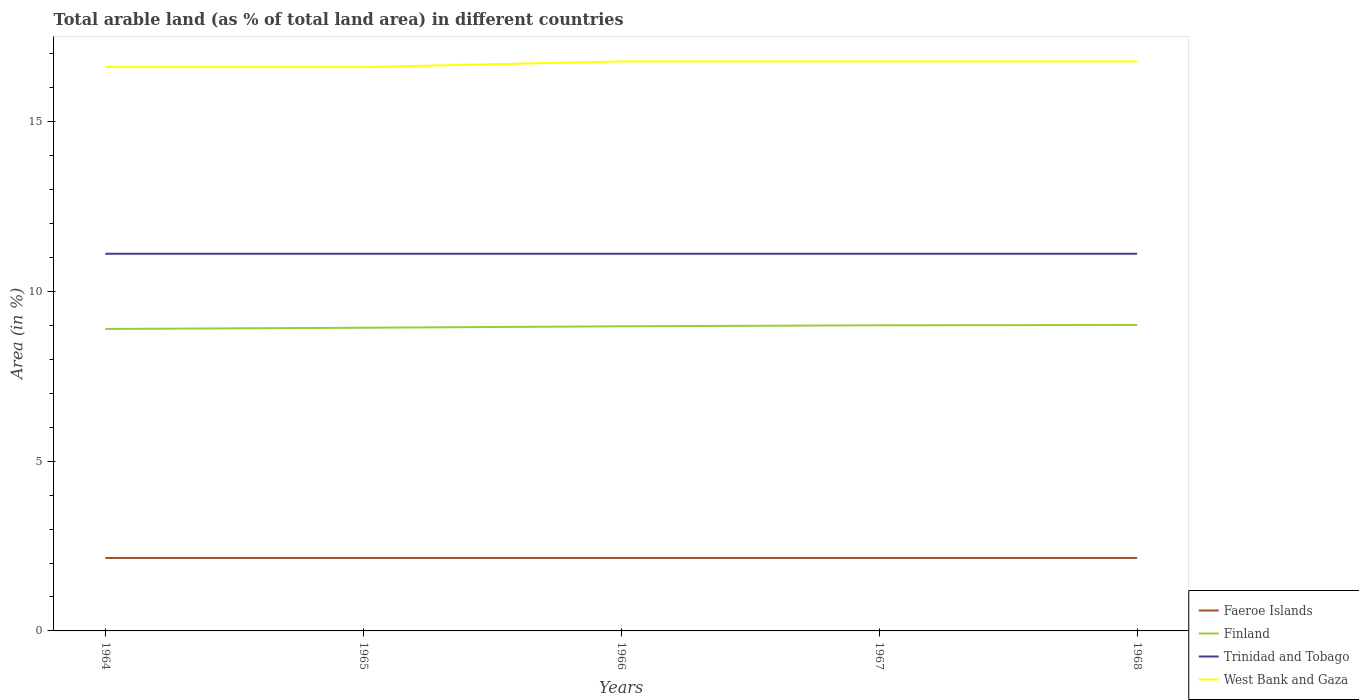Does the line corresponding to Finland intersect with the line corresponding to West Bank and Gaza?
Keep it short and to the point. No. Across all years, what is the maximum percentage of arable land in Faeroe Islands?
Offer a terse response. 2.15. In which year was the percentage of arable land in Faeroe Islands maximum?
Your answer should be compact. 1964. What is the difference between the highest and the second highest percentage of arable land in Trinidad and Tobago?
Keep it short and to the point. 0. Is the percentage of arable land in Trinidad and Tobago strictly greater than the percentage of arable land in West Bank and Gaza over the years?
Provide a short and direct response. Yes. How many lines are there?
Keep it short and to the point. 4. How many years are there in the graph?
Keep it short and to the point. 5. What is the difference between two consecutive major ticks on the Y-axis?
Provide a short and direct response. 5. Are the values on the major ticks of Y-axis written in scientific E-notation?
Offer a terse response. No. Does the graph contain any zero values?
Keep it short and to the point. No. Does the graph contain grids?
Your answer should be very brief. No. What is the title of the graph?
Your answer should be very brief. Total arable land (as % of total land area) in different countries. What is the label or title of the X-axis?
Provide a succinct answer. Years. What is the label or title of the Y-axis?
Offer a very short reply. Area (in %). What is the Area (in %) of Faeroe Islands in 1964?
Give a very brief answer. 2.15. What is the Area (in %) of Finland in 1964?
Give a very brief answer. 8.9. What is the Area (in %) of Trinidad and Tobago in 1964?
Offer a very short reply. 11.11. What is the Area (in %) in West Bank and Gaza in 1964?
Ensure brevity in your answer.  16.61. What is the Area (in %) in Faeroe Islands in 1965?
Make the answer very short. 2.15. What is the Area (in %) of Finland in 1965?
Offer a very short reply. 8.93. What is the Area (in %) of Trinidad and Tobago in 1965?
Offer a very short reply. 11.11. What is the Area (in %) in West Bank and Gaza in 1965?
Provide a short and direct response. 16.61. What is the Area (in %) in Faeroe Islands in 1966?
Offer a very short reply. 2.15. What is the Area (in %) in Finland in 1966?
Offer a terse response. 8.97. What is the Area (in %) in Trinidad and Tobago in 1966?
Offer a very short reply. 11.11. What is the Area (in %) in West Bank and Gaza in 1966?
Your response must be concise. 16.78. What is the Area (in %) in Faeroe Islands in 1967?
Ensure brevity in your answer.  2.15. What is the Area (in %) in Finland in 1967?
Give a very brief answer. 9. What is the Area (in %) of Trinidad and Tobago in 1967?
Provide a succinct answer. 11.11. What is the Area (in %) of West Bank and Gaza in 1967?
Provide a succinct answer. 16.78. What is the Area (in %) in Faeroe Islands in 1968?
Provide a short and direct response. 2.15. What is the Area (in %) of Finland in 1968?
Give a very brief answer. 9.01. What is the Area (in %) of Trinidad and Tobago in 1968?
Provide a short and direct response. 11.11. What is the Area (in %) in West Bank and Gaza in 1968?
Provide a succinct answer. 16.78. Across all years, what is the maximum Area (in %) of Faeroe Islands?
Provide a short and direct response. 2.15. Across all years, what is the maximum Area (in %) of Finland?
Offer a terse response. 9.01. Across all years, what is the maximum Area (in %) in Trinidad and Tobago?
Make the answer very short. 11.11. Across all years, what is the maximum Area (in %) in West Bank and Gaza?
Provide a succinct answer. 16.78. Across all years, what is the minimum Area (in %) of Faeroe Islands?
Give a very brief answer. 2.15. Across all years, what is the minimum Area (in %) of Finland?
Provide a succinct answer. 8.9. Across all years, what is the minimum Area (in %) of Trinidad and Tobago?
Make the answer very short. 11.11. Across all years, what is the minimum Area (in %) of West Bank and Gaza?
Provide a succinct answer. 16.61. What is the total Area (in %) of Faeroe Islands in the graph?
Provide a succinct answer. 10.74. What is the total Area (in %) of Finland in the graph?
Give a very brief answer. 44.82. What is the total Area (in %) of Trinidad and Tobago in the graph?
Keep it short and to the point. 55.56. What is the total Area (in %) of West Bank and Gaza in the graph?
Offer a terse response. 83.55. What is the difference between the Area (in %) in Faeroe Islands in 1964 and that in 1965?
Make the answer very short. 0. What is the difference between the Area (in %) of Finland in 1964 and that in 1965?
Make the answer very short. -0.04. What is the difference between the Area (in %) in West Bank and Gaza in 1964 and that in 1965?
Offer a terse response. 0. What is the difference between the Area (in %) in Faeroe Islands in 1964 and that in 1966?
Offer a very short reply. 0. What is the difference between the Area (in %) of Finland in 1964 and that in 1966?
Ensure brevity in your answer.  -0.08. What is the difference between the Area (in %) of Trinidad and Tobago in 1964 and that in 1966?
Your response must be concise. 0. What is the difference between the Area (in %) of West Bank and Gaza in 1964 and that in 1966?
Give a very brief answer. -0.17. What is the difference between the Area (in %) in Faeroe Islands in 1964 and that in 1967?
Your answer should be compact. 0. What is the difference between the Area (in %) of Finland in 1964 and that in 1967?
Give a very brief answer. -0.11. What is the difference between the Area (in %) in West Bank and Gaza in 1964 and that in 1967?
Provide a short and direct response. -0.17. What is the difference between the Area (in %) of Faeroe Islands in 1964 and that in 1968?
Keep it short and to the point. 0. What is the difference between the Area (in %) in Finland in 1964 and that in 1968?
Offer a terse response. -0.12. What is the difference between the Area (in %) in Trinidad and Tobago in 1964 and that in 1968?
Give a very brief answer. 0. What is the difference between the Area (in %) of West Bank and Gaza in 1964 and that in 1968?
Provide a short and direct response. -0.17. What is the difference between the Area (in %) of Finland in 1965 and that in 1966?
Offer a terse response. -0.04. What is the difference between the Area (in %) of Trinidad and Tobago in 1965 and that in 1966?
Offer a terse response. 0. What is the difference between the Area (in %) in West Bank and Gaza in 1965 and that in 1966?
Offer a very short reply. -0.17. What is the difference between the Area (in %) of Faeroe Islands in 1965 and that in 1967?
Provide a succinct answer. 0. What is the difference between the Area (in %) of Finland in 1965 and that in 1967?
Offer a terse response. -0.07. What is the difference between the Area (in %) in West Bank and Gaza in 1965 and that in 1967?
Your answer should be very brief. -0.17. What is the difference between the Area (in %) in Finland in 1965 and that in 1968?
Keep it short and to the point. -0.08. What is the difference between the Area (in %) in Trinidad and Tobago in 1965 and that in 1968?
Ensure brevity in your answer.  0. What is the difference between the Area (in %) of West Bank and Gaza in 1965 and that in 1968?
Keep it short and to the point. -0.17. What is the difference between the Area (in %) of Finland in 1966 and that in 1967?
Your answer should be compact. -0.03. What is the difference between the Area (in %) in Trinidad and Tobago in 1966 and that in 1967?
Make the answer very short. 0. What is the difference between the Area (in %) of West Bank and Gaza in 1966 and that in 1967?
Make the answer very short. 0. What is the difference between the Area (in %) in Faeroe Islands in 1966 and that in 1968?
Your answer should be compact. 0. What is the difference between the Area (in %) of Finland in 1966 and that in 1968?
Offer a very short reply. -0.04. What is the difference between the Area (in %) in Finland in 1967 and that in 1968?
Provide a succinct answer. -0.01. What is the difference between the Area (in %) of Trinidad and Tobago in 1967 and that in 1968?
Your answer should be very brief. 0. What is the difference between the Area (in %) of Faeroe Islands in 1964 and the Area (in %) of Finland in 1965?
Provide a succinct answer. -6.78. What is the difference between the Area (in %) of Faeroe Islands in 1964 and the Area (in %) of Trinidad and Tobago in 1965?
Offer a terse response. -8.96. What is the difference between the Area (in %) of Faeroe Islands in 1964 and the Area (in %) of West Bank and Gaza in 1965?
Offer a very short reply. -14.46. What is the difference between the Area (in %) in Finland in 1964 and the Area (in %) in Trinidad and Tobago in 1965?
Ensure brevity in your answer.  -2.22. What is the difference between the Area (in %) of Finland in 1964 and the Area (in %) of West Bank and Gaza in 1965?
Your response must be concise. -7.72. What is the difference between the Area (in %) in Trinidad and Tobago in 1964 and the Area (in %) in West Bank and Gaza in 1965?
Make the answer very short. -5.5. What is the difference between the Area (in %) in Faeroe Islands in 1964 and the Area (in %) in Finland in 1966?
Provide a short and direct response. -6.83. What is the difference between the Area (in %) of Faeroe Islands in 1964 and the Area (in %) of Trinidad and Tobago in 1966?
Offer a very short reply. -8.96. What is the difference between the Area (in %) of Faeroe Islands in 1964 and the Area (in %) of West Bank and Gaza in 1966?
Your answer should be compact. -14.63. What is the difference between the Area (in %) of Finland in 1964 and the Area (in %) of Trinidad and Tobago in 1966?
Provide a short and direct response. -2.22. What is the difference between the Area (in %) in Finland in 1964 and the Area (in %) in West Bank and Gaza in 1966?
Your answer should be very brief. -7.88. What is the difference between the Area (in %) of Trinidad and Tobago in 1964 and the Area (in %) of West Bank and Gaza in 1966?
Provide a short and direct response. -5.67. What is the difference between the Area (in %) in Faeroe Islands in 1964 and the Area (in %) in Finland in 1967?
Your answer should be compact. -6.85. What is the difference between the Area (in %) in Faeroe Islands in 1964 and the Area (in %) in Trinidad and Tobago in 1967?
Your response must be concise. -8.96. What is the difference between the Area (in %) of Faeroe Islands in 1964 and the Area (in %) of West Bank and Gaza in 1967?
Provide a short and direct response. -14.63. What is the difference between the Area (in %) of Finland in 1964 and the Area (in %) of Trinidad and Tobago in 1967?
Your answer should be very brief. -2.22. What is the difference between the Area (in %) of Finland in 1964 and the Area (in %) of West Bank and Gaza in 1967?
Ensure brevity in your answer.  -7.88. What is the difference between the Area (in %) of Trinidad and Tobago in 1964 and the Area (in %) of West Bank and Gaza in 1967?
Make the answer very short. -5.67. What is the difference between the Area (in %) of Faeroe Islands in 1964 and the Area (in %) of Finland in 1968?
Provide a short and direct response. -6.86. What is the difference between the Area (in %) in Faeroe Islands in 1964 and the Area (in %) in Trinidad and Tobago in 1968?
Give a very brief answer. -8.96. What is the difference between the Area (in %) of Faeroe Islands in 1964 and the Area (in %) of West Bank and Gaza in 1968?
Your answer should be very brief. -14.63. What is the difference between the Area (in %) in Finland in 1964 and the Area (in %) in Trinidad and Tobago in 1968?
Offer a very short reply. -2.22. What is the difference between the Area (in %) of Finland in 1964 and the Area (in %) of West Bank and Gaza in 1968?
Your answer should be compact. -7.88. What is the difference between the Area (in %) in Trinidad and Tobago in 1964 and the Area (in %) in West Bank and Gaza in 1968?
Make the answer very short. -5.67. What is the difference between the Area (in %) of Faeroe Islands in 1965 and the Area (in %) of Finland in 1966?
Your answer should be very brief. -6.83. What is the difference between the Area (in %) in Faeroe Islands in 1965 and the Area (in %) in Trinidad and Tobago in 1966?
Your answer should be compact. -8.96. What is the difference between the Area (in %) in Faeroe Islands in 1965 and the Area (in %) in West Bank and Gaza in 1966?
Give a very brief answer. -14.63. What is the difference between the Area (in %) in Finland in 1965 and the Area (in %) in Trinidad and Tobago in 1966?
Provide a short and direct response. -2.18. What is the difference between the Area (in %) of Finland in 1965 and the Area (in %) of West Bank and Gaza in 1966?
Your answer should be very brief. -7.85. What is the difference between the Area (in %) of Trinidad and Tobago in 1965 and the Area (in %) of West Bank and Gaza in 1966?
Provide a short and direct response. -5.67. What is the difference between the Area (in %) of Faeroe Islands in 1965 and the Area (in %) of Finland in 1967?
Your response must be concise. -6.85. What is the difference between the Area (in %) in Faeroe Islands in 1965 and the Area (in %) in Trinidad and Tobago in 1967?
Ensure brevity in your answer.  -8.96. What is the difference between the Area (in %) of Faeroe Islands in 1965 and the Area (in %) of West Bank and Gaza in 1967?
Ensure brevity in your answer.  -14.63. What is the difference between the Area (in %) in Finland in 1965 and the Area (in %) in Trinidad and Tobago in 1967?
Your answer should be compact. -2.18. What is the difference between the Area (in %) in Finland in 1965 and the Area (in %) in West Bank and Gaza in 1967?
Offer a very short reply. -7.85. What is the difference between the Area (in %) in Trinidad and Tobago in 1965 and the Area (in %) in West Bank and Gaza in 1967?
Provide a short and direct response. -5.67. What is the difference between the Area (in %) of Faeroe Islands in 1965 and the Area (in %) of Finland in 1968?
Provide a succinct answer. -6.86. What is the difference between the Area (in %) of Faeroe Islands in 1965 and the Area (in %) of Trinidad and Tobago in 1968?
Your answer should be compact. -8.96. What is the difference between the Area (in %) in Faeroe Islands in 1965 and the Area (in %) in West Bank and Gaza in 1968?
Offer a very short reply. -14.63. What is the difference between the Area (in %) in Finland in 1965 and the Area (in %) in Trinidad and Tobago in 1968?
Make the answer very short. -2.18. What is the difference between the Area (in %) of Finland in 1965 and the Area (in %) of West Bank and Gaza in 1968?
Your answer should be compact. -7.85. What is the difference between the Area (in %) of Trinidad and Tobago in 1965 and the Area (in %) of West Bank and Gaza in 1968?
Provide a short and direct response. -5.67. What is the difference between the Area (in %) in Faeroe Islands in 1966 and the Area (in %) in Finland in 1967?
Offer a very short reply. -6.85. What is the difference between the Area (in %) of Faeroe Islands in 1966 and the Area (in %) of Trinidad and Tobago in 1967?
Your response must be concise. -8.96. What is the difference between the Area (in %) in Faeroe Islands in 1966 and the Area (in %) in West Bank and Gaza in 1967?
Offer a terse response. -14.63. What is the difference between the Area (in %) of Finland in 1966 and the Area (in %) of Trinidad and Tobago in 1967?
Your response must be concise. -2.14. What is the difference between the Area (in %) of Finland in 1966 and the Area (in %) of West Bank and Gaza in 1967?
Provide a succinct answer. -7.8. What is the difference between the Area (in %) of Trinidad and Tobago in 1966 and the Area (in %) of West Bank and Gaza in 1967?
Your response must be concise. -5.67. What is the difference between the Area (in %) in Faeroe Islands in 1966 and the Area (in %) in Finland in 1968?
Your answer should be very brief. -6.86. What is the difference between the Area (in %) in Faeroe Islands in 1966 and the Area (in %) in Trinidad and Tobago in 1968?
Make the answer very short. -8.96. What is the difference between the Area (in %) in Faeroe Islands in 1966 and the Area (in %) in West Bank and Gaza in 1968?
Provide a short and direct response. -14.63. What is the difference between the Area (in %) of Finland in 1966 and the Area (in %) of Trinidad and Tobago in 1968?
Give a very brief answer. -2.14. What is the difference between the Area (in %) of Finland in 1966 and the Area (in %) of West Bank and Gaza in 1968?
Provide a succinct answer. -7.8. What is the difference between the Area (in %) of Trinidad and Tobago in 1966 and the Area (in %) of West Bank and Gaza in 1968?
Offer a very short reply. -5.67. What is the difference between the Area (in %) of Faeroe Islands in 1967 and the Area (in %) of Finland in 1968?
Offer a terse response. -6.86. What is the difference between the Area (in %) of Faeroe Islands in 1967 and the Area (in %) of Trinidad and Tobago in 1968?
Provide a short and direct response. -8.96. What is the difference between the Area (in %) of Faeroe Islands in 1967 and the Area (in %) of West Bank and Gaza in 1968?
Keep it short and to the point. -14.63. What is the difference between the Area (in %) in Finland in 1967 and the Area (in %) in Trinidad and Tobago in 1968?
Keep it short and to the point. -2.11. What is the difference between the Area (in %) in Finland in 1967 and the Area (in %) in West Bank and Gaza in 1968?
Ensure brevity in your answer.  -7.77. What is the difference between the Area (in %) in Trinidad and Tobago in 1967 and the Area (in %) in West Bank and Gaza in 1968?
Keep it short and to the point. -5.67. What is the average Area (in %) in Faeroe Islands per year?
Give a very brief answer. 2.15. What is the average Area (in %) in Finland per year?
Your answer should be very brief. 8.96. What is the average Area (in %) in Trinidad and Tobago per year?
Provide a short and direct response. 11.11. What is the average Area (in %) of West Bank and Gaza per year?
Offer a very short reply. 16.71. In the year 1964, what is the difference between the Area (in %) in Faeroe Islands and Area (in %) in Finland?
Keep it short and to the point. -6.75. In the year 1964, what is the difference between the Area (in %) of Faeroe Islands and Area (in %) of Trinidad and Tobago?
Keep it short and to the point. -8.96. In the year 1964, what is the difference between the Area (in %) in Faeroe Islands and Area (in %) in West Bank and Gaza?
Provide a succinct answer. -14.46. In the year 1964, what is the difference between the Area (in %) in Finland and Area (in %) in Trinidad and Tobago?
Keep it short and to the point. -2.22. In the year 1964, what is the difference between the Area (in %) in Finland and Area (in %) in West Bank and Gaza?
Your answer should be compact. -7.72. In the year 1964, what is the difference between the Area (in %) of Trinidad and Tobago and Area (in %) of West Bank and Gaza?
Keep it short and to the point. -5.5. In the year 1965, what is the difference between the Area (in %) of Faeroe Islands and Area (in %) of Finland?
Make the answer very short. -6.78. In the year 1965, what is the difference between the Area (in %) in Faeroe Islands and Area (in %) in Trinidad and Tobago?
Keep it short and to the point. -8.96. In the year 1965, what is the difference between the Area (in %) of Faeroe Islands and Area (in %) of West Bank and Gaza?
Your answer should be compact. -14.46. In the year 1965, what is the difference between the Area (in %) in Finland and Area (in %) in Trinidad and Tobago?
Offer a very short reply. -2.18. In the year 1965, what is the difference between the Area (in %) of Finland and Area (in %) of West Bank and Gaza?
Keep it short and to the point. -7.68. In the year 1965, what is the difference between the Area (in %) in Trinidad and Tobago and Area (in %) in West Bank and Gaza?
Your answer should be compact. -5.5. In the year 1966, what is the difference between the Area (in %) in Faeroe Islands and Area (in %) in Finland?
Your answer should be compact. -6.83. In the year 1966, what is the difference between the Area (in %) in Faeroe Islands and Area (in %) in Trinidad and Tobago?
Provide a short and direct response. -8.96. In the year 1966, what is the difference between the Area (in %) of Faeroe Islands and Area (in %) of West Bank and Gaza?
Give a very brief answer. -14.63. In the year 1966, what is the difference between the Area (in %) in Finland and Area (in %) in Trinidad and Tobago?
Provide a succinct answer. -2.14. In the year 1966, what is the difference between the Area (in %) in Finland and Area (in %) in West Bank and Gaza?
Your response must be concise. -7.8. In the year 1966, what is the difference between the Area (in %) of Trinidad and Tobago and Area (in %) of West Bank and Gaza?
Offer a terse response. -5.67. In the year 1967, what is the difference between the Area (in %) of Faeroe Islands and Area (in %) of Finland?
Your response must be concise. -6.85. In the year 1967, what is the difference between the Area (in %) of Faeroe Islands and Area (in %) of Trinidad and Tobago?
Your answer should be compact. -8.96. In the year 1967, what is the difference between the Area (in %) of Faeroe Islands and Area (in %) of West Bank and Gaza?
Offer a very short reply. -14.63. In the year 1967, what is the difference between the Area (in %) of Finland and Area (in %) of Trinidad and Tobago?
Ensure brevity in your answer.  -2.11. In the year 1967, what is the difference between the Area (in %) of Finland and Area (in %) of West Bank and Gaza?
Your answer should be very brief. -7.77. In the year 1967, what is the difference between the Area (in %) of Trinidad and Tobago and Area (in %) of West Bank and Gaza?
Your response must be concise. -5.67. In the year 1968, what is the difference between the Area (in %) of Faeroe Islands and Area (in %) of Finland?
Offer a terse response. -6.86. In the year 1968, what is the difference between the Area (in %) of Faeroe Islands and Area (in %) of Trinidad and Tobago?
Give a very brief answer. -8.96. In the year 1968, what is the difference between the Area (in %) of Faeroe Islands and Area (in %) of West Bank and Gaza?
Your answer should be very brief. -14.63. In the year 1968, what is the difference between the Area (in %) in Finland and Area (in %) in Trinidad and Tobago?
Keep it short and to the point. -2.1. In the year 1968, what is the difference between the Area (in %) in Finland and Area (in %) in West Bank and Gaza?
Provide a short and direct response. -7.76. In the year 1968, what is the difference between the Area (in %) in Trinidad and Tobago and Area (in %) in West Bank and Gaza?
Provide a short and direct response. -5.67. What is the ratio of the Area (in %) of Faeroe Islands in 1964 to that in 1966?
Offer a terse response. 1. What is the ratio of the Area (in %) in West Bank and Gaza in 1964 to that in 1966?
Your answer should be very brief. 0.99. What is the ratio of the Area (in %) of West Bank and Gaza in 1964 to that in 1967?
Your response must be concise. 0.99. What is the ratio of the Area (in %) of Finland in 1964 to that in 1968?
Offer a very short reply. 0.99. What is the ratio of the Area (in %) of Trinidad and Tobago in 1964 to that in 1968?
Provide a short and direct response. 1. What is the ratio of the Area (in %) in Faeroe Islands in 1965 to that in 1966?
Your answer should be compact. 1. What is the ratio of the Area (in %) of Finland in 1965 to that in 1966?
Your answer should be very brief. 1. What is the ratio of the Area (in %) in Trinidad and Tobago in 1965 to that in 1966?
Provide a succinct answer. 1. What is the ratio of the Area (in %) of Finland in 1965 to that in 1967?
Provide a succinct answer. 0.99. What is the ratio of the Area (in %) in Trinidad and Tobago in 1965 to that in 1967?
Make the answer very short. 1. What is the ratio of the Area (in %) in West Bank and Gaza in 1965 to that in 1967?
Give a very brief answer. 0.99. What is the ratio of the Area (in %) in Faeroe Islands in 1965 to that in 1968?
Provide a succinct answer. 1. What is the ratio of the Area (in %) of Finland in 1965 to that in 1968?
Your response must be concise. 0.99. What is the ratio of the Area (in %) of West Bank and Gaza in 1965 to that in 1968?
Make the answer very short. 0.99. What is the ratio of the Area (in %) in Faeroe Islands in 1966 to that in 1967?
Your response must be concise. 1. What is the ratio of the Area (in %) of Trinidad and Tobago in 1966 to that in 1967?
Provide a short and direct response. 1. What is the ratio of the Area (in %) in Faeroe Islands in 1966 to that in 1968?
Give a very brief answer. 1. What is the ratio of the Area (in %) in Finland in 1966 to that in 1968?
Provide a succinct answer. 1. What is the ratio of the Area (in %) in Finland in 1967 to that in 1968?
Keep it short and to the point. 1. What is the ratio of the Area (in %) of Trinidad and Tobago in 1967 to that in 1968?
Make the answer very short. 1. What is the difference between the highest and the second highest Area (in %) of Faeroe Islands?
Offer a very short reply. 0. What is the difference between the highest and the second highest Area (in %) of Finland?
Offer a very short reply. 0.01. What is the difference between the highest and the second highest Area (in %) in West Bank and Gaza?
Make the answer very short. 0. What is the difference between the highest and the lowest Area (in %) of Finland?
Offer a terse response. 0.12. What is the difference between the highest and the lowest Area (in %) in West Bank and Gaza?
Offer a very short reply. 0.17. 